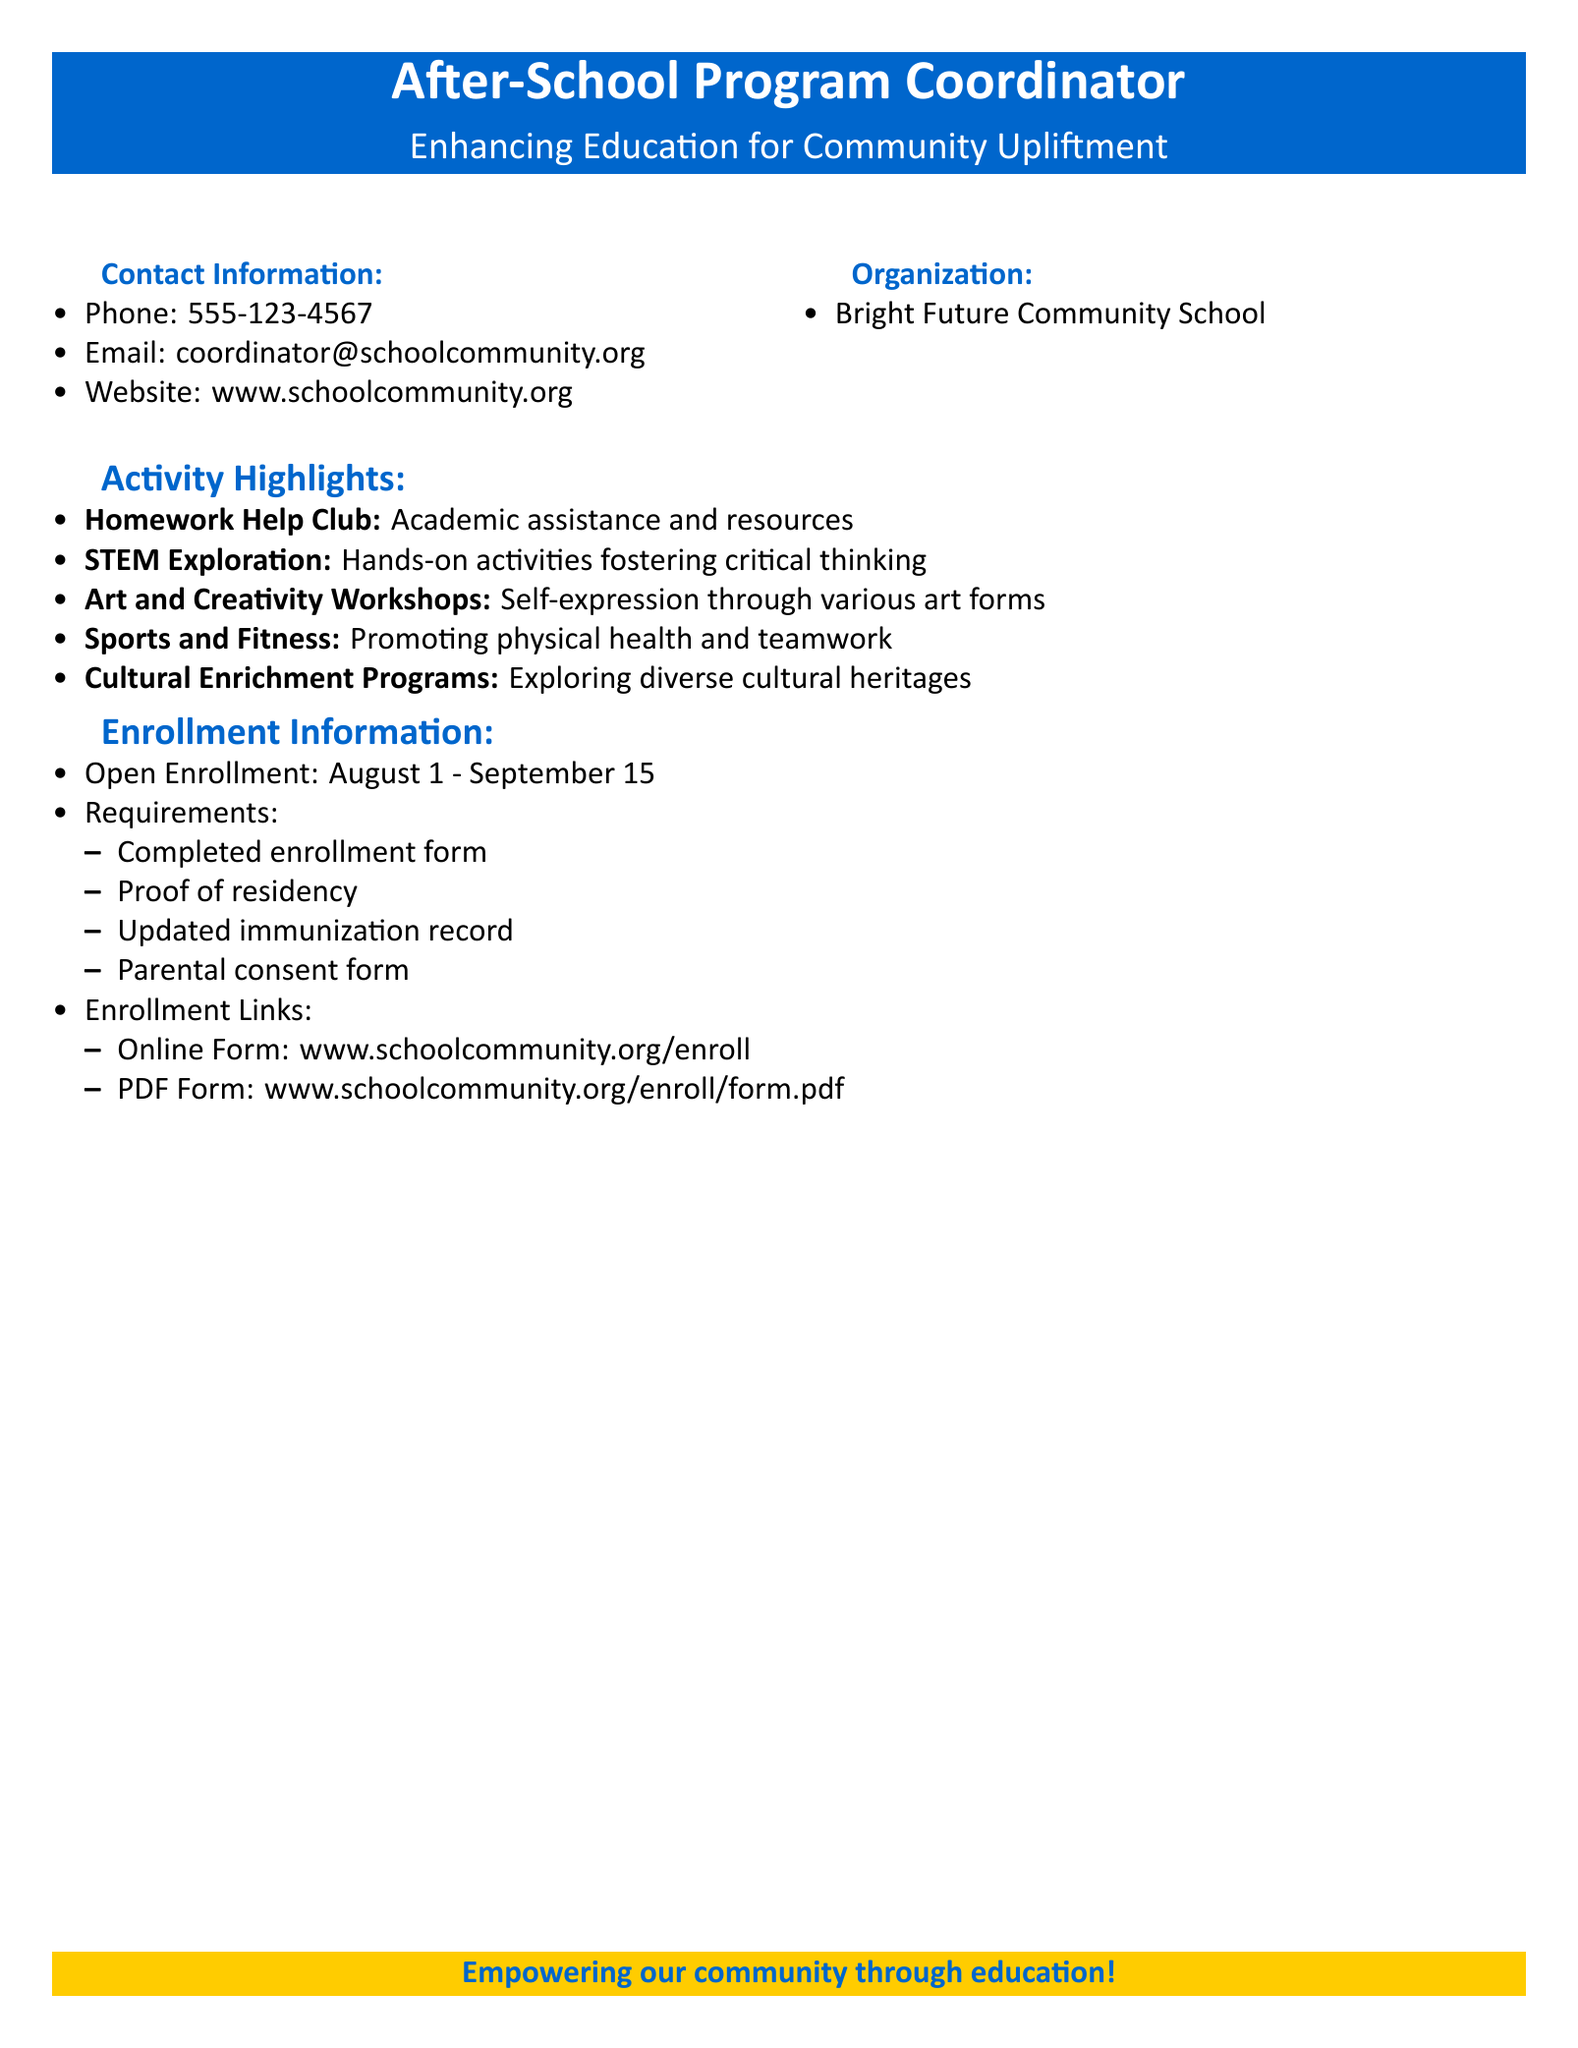What is the phone number for the After-School Program Coordinator? The document lists the phone number in the contact information section.
Answer: 555-123-4567 What is the email address for the After-School Program Coordinator? The document provides the email address in the contact information section.
Answer: coordinator@schoolcommunity.org What is the enrollment period for the After-School Program? The document specifies the open enrollment dates in the enrollment information section.
Answer: August 1 - September 15 What activity promotes physical health and teamwork? The document mentions this activity in the activity highlights section.
Answer: Sports and Fitness What is required to enroll in the After-School Program? The document lists the requirements in the enrollment information section.
Answer: Completed enrollment form Which organization offers this After-School Program? The document includes the organization's name in the organization section.
Answer: Bright Future Community School What type of workshops are offered for self-expression? The document details this in the activity highlights section.
Answer: Art and Creativity Workshops Where can the online enrollment form be found? The document provides the link for online enrollment in the enrollment information section.
Answer: www.schoolcommunity.org/enroll 